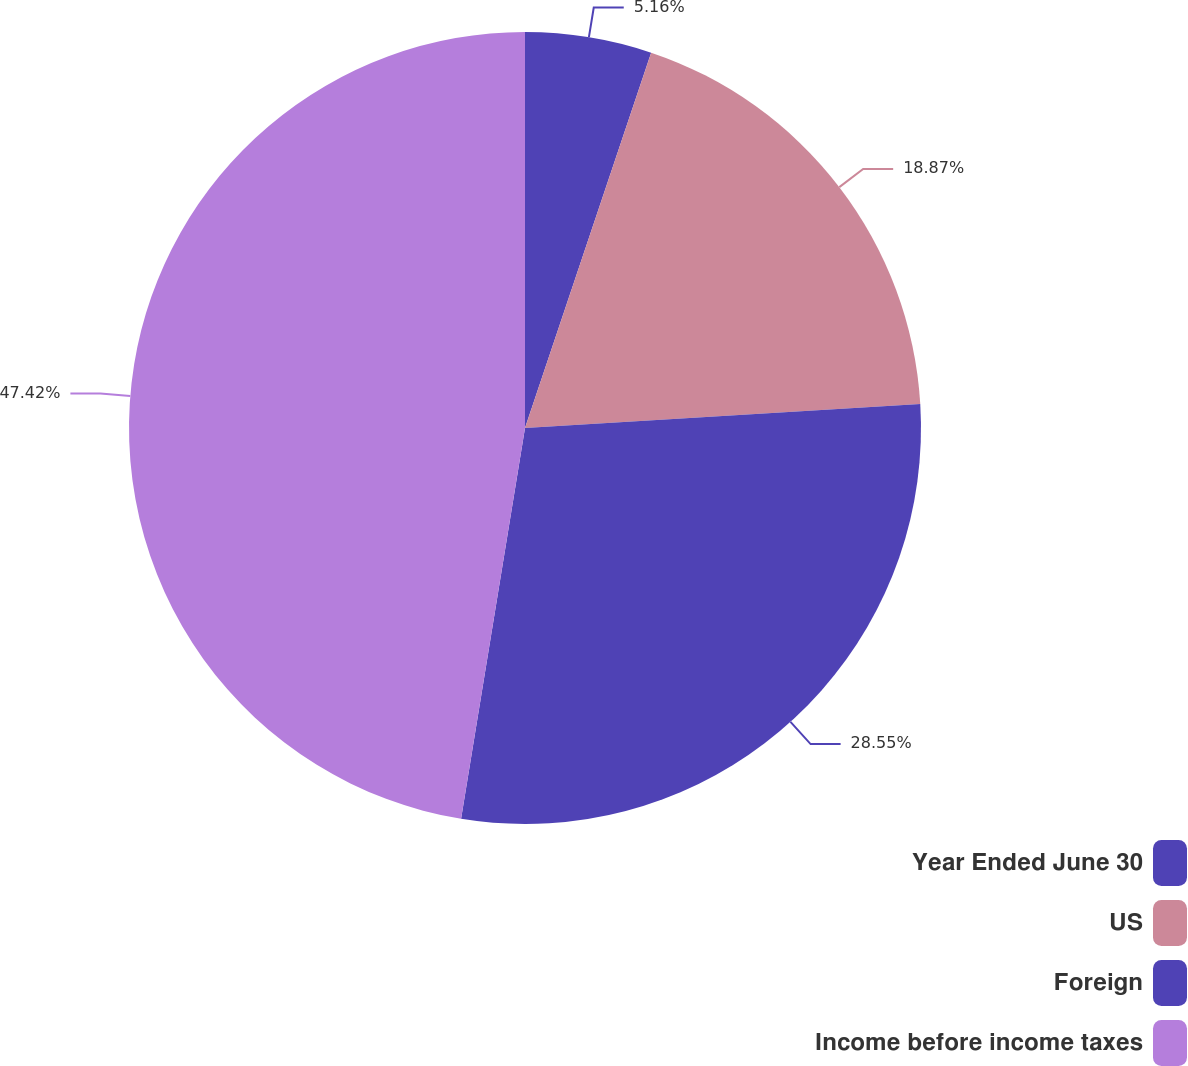Convert chart. <chart><loc_0><loc_0><loc_500><loc_500><pie_chart><fcel>Year Ended June 30<fcel>US<fcel>Foreign<fcel>Income before income taxes<nl><fcel>5.16%<fcel>18.87%<fcel>28.55%<fcel>47.42%<nl></chart> 